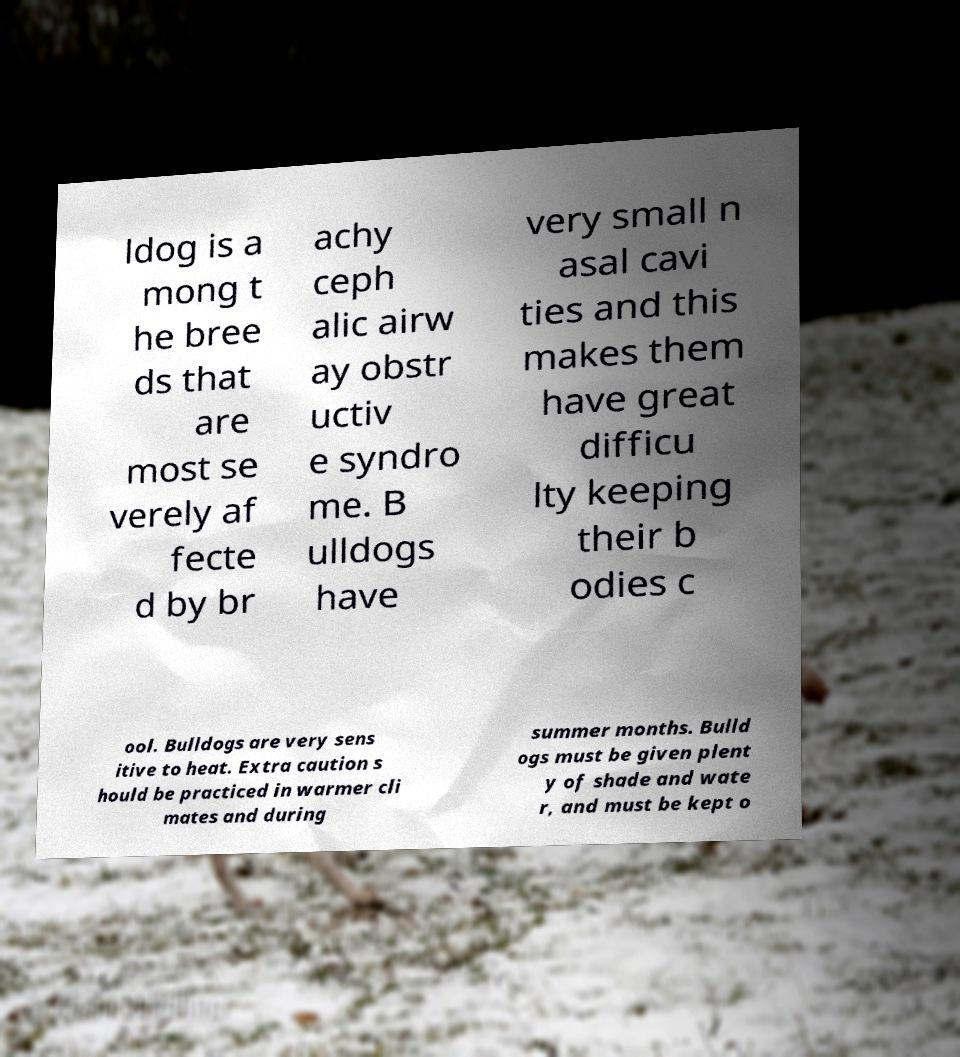Please identify and transcribe the text found in this image. ldog is a mong t he bree ds that are most se verely af fecte d by br achy ceph alic airw ay obstr uctiv e syndro me. B ulldogs have very small n asal cavi ties and this makes them have great difficu lty keeping their b odies c ool. Bulldogs are very sens itive to heat. Extra caution s hould be practiced in warmer cli mates and during summer months. Bulld ogs must be given plent y of shade and wate r, and must be kept o 